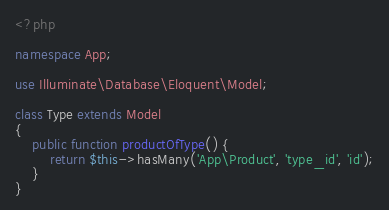<code> <loc_0><loc_0><loc_500><loc_500><_PHP_><?php

namespace App;

use Illuminate\Database\Eloquent\Model;

class Type extends Model
{
    public function productOfType() {
        return $this->hasMany('App\Product', 'type_id', 'id');
    }
}
</code> 